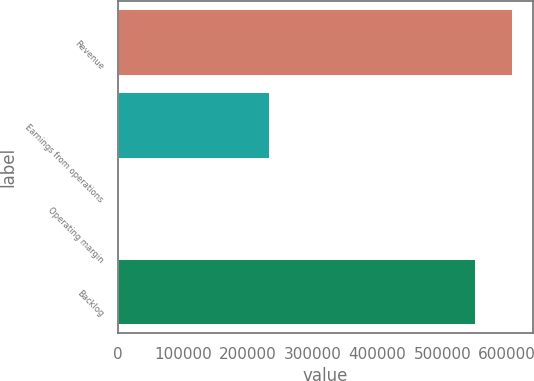Convert chart. <chart><loc_0><loc_0><loc_500><loc_500><bar_chart><fcel>Revenue<fcel>Earnings from operations<fcel>Operating margin<fcel>Backlog<nl><fcel>608899<fcel>233803<fcel>41.1<fcel>552000<nl></chart> 